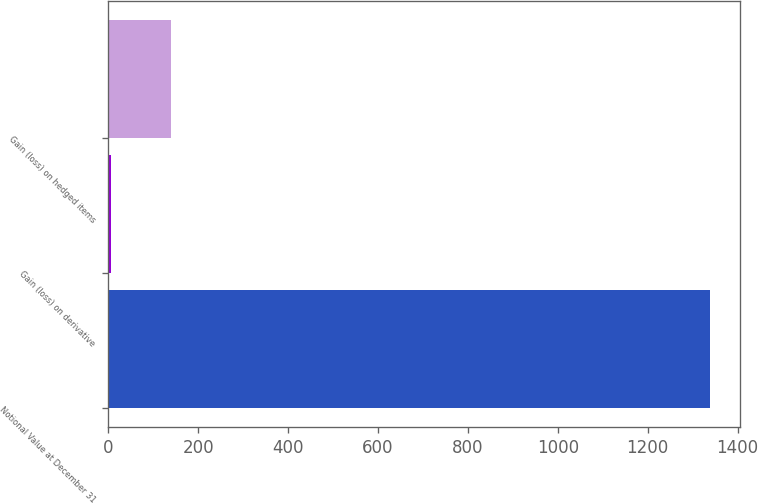<chart> <loc_0><loc_0><loc_500><loc_500><bar_chart><fcel>Notional Value at December 31<fcel>Gain (loss) on derivative<fcel>Gain (loss) on hedged items<nl><fcel>1338<fcel>6<fcel>139.2<nl></chart> 